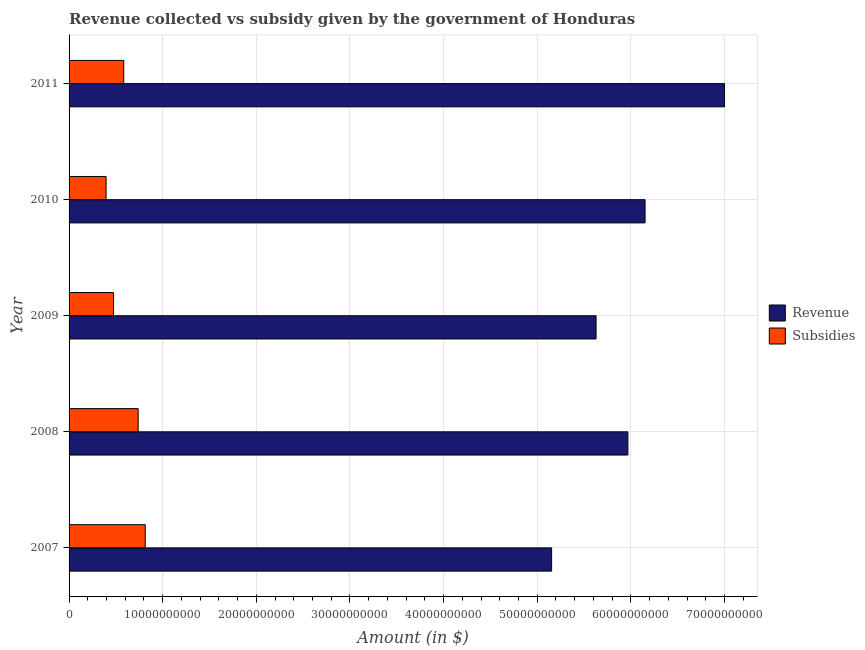Are the number of bars per tick equal to the number of legend labels?
Your answer should be compact. Yes. Are the number of bars on each tick of the Y-axis equal?
Offer a terse response. Yes. How many bars are there on the 2nd tick from the top?
Your answer should be very brief. 2. How many bars are there on the 1st tick from the bottom?
Provide a short and direct response. 2. What is the label of the 2nd group of bars from the top?
Give a very brief answer. 2010. In how many cases, is the number of bars for a given year not equal to the number of legend labels?
Your answer should be very brief. 0. What is the amount of subsidies given in 2011?
Provide a succinct answer. 5.84e+09. Across all years, what is the maximum amount of revenue collected?
Offer a very short reply. 7.00e+1. Across all years, what is the minimum amount of revenue collected?
Offer a very short reply. 5.15e+1. What is the total amount of revenue collected in the graph?
Provide a short and direct response. 2.99e+11. What is the difference between the amount of revenue collected in 2007 and that in 2009?
Provide a succinct answer. -4.75e+09. What is the difference between the amount of subsidies given in 2007 and the amount of revenue collected in 2011?
Offer a very short reply. -6.19e+1. What is the average amount of subsidies given per year?
Your answer should be very brief. 6.01e+09. In the year 2011, what is the difference between the amount of revenue collected and amount of subsidies given?
Give a very brief answer. 6.42e+1. In how many years, is the amount of subsidies given greater than 22000000000 $?
Provide a short and direct response. 0. What is the ratio of the amount of revenue collected in 2008 to that in 2011?
Your answer should be very brief. 0.85. Is the amount of revenue collected in 2007 less than that in 2009?
Offer a very short reply. Yes. Is the difference between the amount of subsidies given in 2010 and 2011 greater than the difference between the amount of revenue collected in 2010 and 2011?
Make the answer very short. Yes. What is the difference between the highest and the second highest amount of revenue collected?
Give a very brief answer. 8.49e+09. What is the difference between the highest and the lowest amount of subsidies given?
Provide a short and direct response. 4.18e+09. In how many years, is the amount of subsidies given greater than the average amount of subsidies given taken over all years?
Offer a terse response. 2. Is the sum of the amount of revenue collected in 2008 and 2011 greater than the maximum amount of subsidies given across all years?
Provide a succinct answer. Yes. What does the 2nd bar from the top in 2010 represents?
Your response must be concise. Revenue. What does the 2nd bar from the bottom in 2010 represents?
Keep it short and to the point. Subsidies. Are the values on the major ticks of X-axis written in scientific E-notation?
Provide a short and direct response. No. How many legend labels are there?
Your response must be concise. 2. What is the title of the graph?
Give a very brief answer. Revenue collected vs subsidy given by the government of Honduras. What is the label or title of the X-axis?
Your answer should be compact. Amount (in $). What is the label or title of the Y-axis?
Your answer should be very brief. Year. What is the Amount (in $) of Revenue in 2007?
Provide a short and direct response. 5.15e+1. What is the Amount (in $) of Subsidies in 2007?
Ensure brevity in your answer.  8.13e+09. What is the Amount (in $) in Revenue in 2008?
Give a very brief answer. 5.97e+1. What is the Amount (in $) in Subsidies in 2008?
Keep it short and to the point. 7.38e+09. What is the Amount (in $) in Revenue in 2009?
Your answer should be very brief. 5.63e+1. What is the Amount (in $) of Subsidies in 2009?
Your answer should be very brief. 4.75e+09. What is the Amount (in $) of Revenue in 2010?
Provide a succinct answer. 6.15e+1. What is the Amount (in $) in Subsidies in 2010?
Give a very brief answer. 3.95e+09. What is the Amount (in $) of Revenue in 2011?
Offer a very short reply. 7.00e+1. What is the Amount (in $) in Subsidies in 2011?
Your answer should be compact. 5.84e+09. Across all years, what is the maximum Amount (in $) of Revenue?
Provide a succinct answer. 7.00e+1. Across all years, what is the maximum Amount (in $) of Subsidies?
Offer a very short reply. 8.13e+09. Across all years, what is the minimum Amount (in $) of Revenue?
Ensure brevity in your answer.  5.15e+1. Across all years, what is the minimum Amount (in $) of Subsidies?
Give a very brief answer. 3.95e+09. What is the total Amount (in $) of Revenue in the graph?
Provide a short and direct response. 2.99e+11. What is the total Amount (in $) of Subsidies in the graph?
Your answer should be very brief. 3.01e+1. What is the difference between the Amount (in $) in Revenue in 2007 and that in 2008?
Ensure brevity in your answer.  -8.15e+09. What is the difference between the Amount (in $) of Subsidies in 2007 and that in 2008?
Provide a short and direct response. 7.53e+08. What is the difference between the Amount (in $) in Revenue in 2007 and that in 2009?
Provide a succinct answer. -4.75e+09. What is the difference between the Amount (in $) in Subsidies in 2007 and that in 2009?
Offer a very short reply. 3.38e+09. What is the difference between the Amount (in $) of Revenue in 2007 and that in 2010?
Make the answer very short. -9.98e+09. What is the difference between the Amount (in $) of Subsidies in 2007 and that in 2010?
Provide a succinct answer. 4.18e+09. What is the difference between the Amount (in $) in Revenue in 2007 and that in 2011?
Offer a terse response. -1.85e+1. What is the difference between the Amount (in $) in Subsidies in 2007 and that in 2011?
Keep it short and to the point. 2.29e+09. What is the difference between the Amount (in $) of Revenue in 2008 and that in 2009?
Your answer should be very brief. 3.40e+09. What is the difference between the Amount (in $) in Subsidies in 2008 and that in 2009?
Your response must be concise. 2.63e+09. What is the difference between the Amount (in $) in Revenue in 2008 and that in 2010?
Offer a terse response. -1.84e+09. What is the difference between the Amount (in $) in Subsidies in 2008 and that in 2010?
Your answer should be very brief. 3.43e+09. What is the difference between the Amount (in $) in Revenue in 2008 and that in 2011?
Provide a short and direct response. -1.03e+1. What is the difference between the Amount (in $) of Subsidies in 2008 and that in 2011?
Your answer should be very brief. 1.54e+09. What is the difference between the Amount (in $) of Revenue in 2009 and that in 2010?
Keep it short and to the point. -5.23e+09. What is the difference between the Amount (in $) in Subsidies in 2009 and that in 2010?
Ensure brevity in your answer.  8.00e+08. What is the difference between the Amount (in $) in Revenue in 2009 and that in 2011?
Ensure brevity in your answer.  -1.37e+1. What is the difference between the Amount (in $) of Subsidies in 2009 and that in 2011?
Your answer should be compact. -1.09e+09. What is the difference between the Amount (in $) in Revenue in 2010 and that in 2011?
Offer a terse response. -8.49e+09. What is the difference between the Amount (in $) in Subsidies in 2010 and that in 2011?
Make the answer very short. -1.89e+09. What is the difference between the Amount (in $) of Revenue in 2007 and the Amount (in $) of Subsidies in 2008?
Your response must be concise. 4.42e+1. What is the difference between the Amount (in $) in Revenue in 2007 and the Amount (in $) in Subsidies in 2009?
Provide a short and direct response. 4.68e+1. What is the difference between the Amount (in $) of Revenue in 2007 and the Amount (in $) of Subsidies in 2010?
Give a very brief answer. 4.76e+1. What is the difference between the Amount (in $) in Revenue in 2007 and the Amount (in $) in Subsidies in 2011?
Ensure brevity in your answer.  4.57e+1. What is the difference between the Amount (in $) in Revenue in 2008 and the Amount (in $) in Subsidies in 2009?
Make the answer very short. 5.49e+1. What is the difference between the Amount (in $) in Revenue in 2008 and the Amount (in $) in Subsidies in 2010?
Provide a short and direct response. 5.57e+1. What is the difference between the Amount (in $) in Revenue in 2008 and the Amount (in $) in Subsidies in 2011?
Ensure brevity in your answer.  5.38e+1. What is the difference between the Amount (in $) of Revenue in 2009 and the Amount (in $) of Subsidies in 2010?
Your response must be concise. 5.23e+1. What is the difference between the Amount (in $) in Revenue in 2009 and the Amount (in $) in Subsidies in 2011?
Your answer should be very brief. 5.04e+1. What is the difference between the Amount (in $) of Revenue in 2010 and the Amount (in $) of Subsidies in 2011?
Your answer should be compact. 5.57e+1. What is the average Amount (in $) in Revenue per year?
Provide a succinct answer. 5.98e+1. What is the average Amount (in $) in Subsidies per year?
Your response must be concise. 6.01e+09. In the year 2007, what is the difference between the Amount (in $) of Revenue and Amount (in $) of Subsidies?
Provide a succinct answer. 4.34e+1. In the year 2008, what is the difference between the Amount (in $) of Revenue and Amount (in $) of Subsidies?
Your answer should be compact. 5.23e+1. In the year 2009, what is the difference between the Amount (in $) in Revenue and Amount (in $) in Subsidies?
Offer a terse response. 5.15e+1. In the year 2010, what is the difference between the Amount (in $) of Revenue and Amount (in $) of Subsidies?
Your answer should be compact. 5.76e+1. In the year 2011, what is the difference between the Amount (in $) in Revenue and Amount (in $) in Subsidies?
Offer a very short reply. 6.42e+1. What is the ratio of the Amount (in $) of Revenue in 2007 to that in 2008?
Offer a terse response. 0.86. What is the ratio of the Amount (in $) of Subsidies in 2007 to that in 2008?
Ensure brevity in your answer.  1.1. What is the ratio of the Amount (in $) in Revenue in 2007 to that in 2009?
Give a very brief answer. 0.92. What is the ratio of the Amount (in $) of Subsidies in 2007 to that in 2009?
Provide a short and direct response. 1.71. What is the ratio of the Amount (in $) of Revenue in 2007 to that in 2010?
Keep it short and to the point. 0.84. What is the ratio of the Amount (in $) in Subsidies in 2007 to that in 2010?
Your answer should be very brief. 2.06. What is the ratio of the Amount (in $) of Revenue in 2007 to that in 2011?
Your answer should be compact. 0.74. What is the ratio of the Amount (in $) of Subsidies in 2007 to that in 2011?
Offer a very short reply. 1.39. What is the ratio of the Amount (in $) in Revenue in 2008 to that in 2009?
Provide a succinct answer. 1.06. What is the ratio of the Amount (in $) in Subsidies in 2008 to that in 2009?
Offer a very short reply. 1.55. What is the ratio of the Amount (in $) of Revenue in 2008 to that in 2010?
Give a very brief answer. 0.97. What is the ratio of the Amount (in $) of Subsidies in 2008 to that in 2010?
Your answer should be compact. 1.87. What is the ratio of the Amount (in $) of Revenue in 2008 to that in 2011?
Your answer should be compact. 0.85. What is the ratio of the Amount (in $) of Subsidies in 2008 to that in 2011?
Your response must be concise. 1.26. What is the ratio of the Amount (in $) of Revenue in 2009 to that in 2010?
Provide a short and direct response. 0.91. What is the ratio of the Amount (in $) of Subsidies in 2009 to that in 2010?
Your response must be concise. 1.2. What is the ratio of the Amount (in $) of Revenue in 2009 to that in 2011?
Provide a succinct answer. 0.8. What is the ratio of the Amount (in $) of Subsidies in 2009 to that in 2011?
Your answer should be very brief. 0.81. What is the ratio of the Amount (in $) in Revenue in 2010 to that in 2011?
Your response must be concise. 0.88. What is the ratio of the Amount (in $) in Subsidies in 2010 to that in 2011?
Your response must be concise. 0.68. What is the difference between the highest and the second highest Amount (in $) of Revenue?
Your response must be concise. 8.49e+09. What is the difference between the highest and the second highest Amount (in $) in Subsidies?
Give a very brief answer. 7.53e+08. What is the difference between the highest and the lowest Amount (in $) in Revenue?
Provide a succinct answer. 1.85e+1. What is the difference between the highest and the lowest Amount (in $) in Subsidies?
Your answer should be compact. 4.18e+09. 